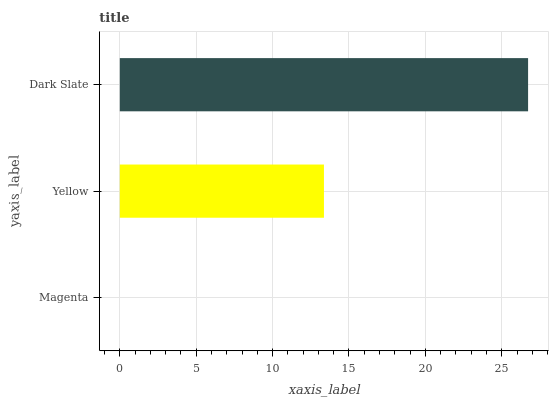Is Magenta the minimum?
Answer yes or no. Yes. Is Dark Slate the maximum?
Answer yes or no. Yes. Is Yellow the minimum?
Answer yes or no. No. Is Yellow the maximum?
Answer yes or no. No. Is Yellow greater than Magenta?
Answer yes or no. Yes. Is Magenta less than Yellow?
Answer yes or no. Yes. Is Magenta greater than Yellow?
Answer yes or no. No. Is Yellow less than Magenta?
Answer yes or no. No. Is Yellow the high median?
Answer yes or no. Yes. Is Yellow the low median?
Answer yes or no. Yes. Is Dark Slate the high median?
Answer yes or no. No. Is Dark Slate the low median?
Answer yes or no. No. 